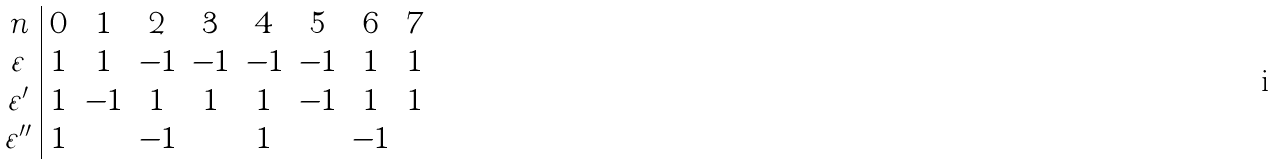<formula> <loc_0><loc_0><loc_500><loc_500>\begin{array} { c | c c c c c c c c } n & 0 & 1 & 2 & 3 & 4 & 5 & 6 & 7 \\ \varepsilon & 1 & 1 & - 1 & - 1 & - 1 & - 1 & 1 & 1 \\ \varepsilon ^ { \prime } & 1 & - 1 & 1 & 1 & 1 & - 1 & 1 & 1 \\ \varepsilon ^ { \prime \prime } & 1 & & - 1 & & 1 & & - 1 & \\ \end{array}</formula> 